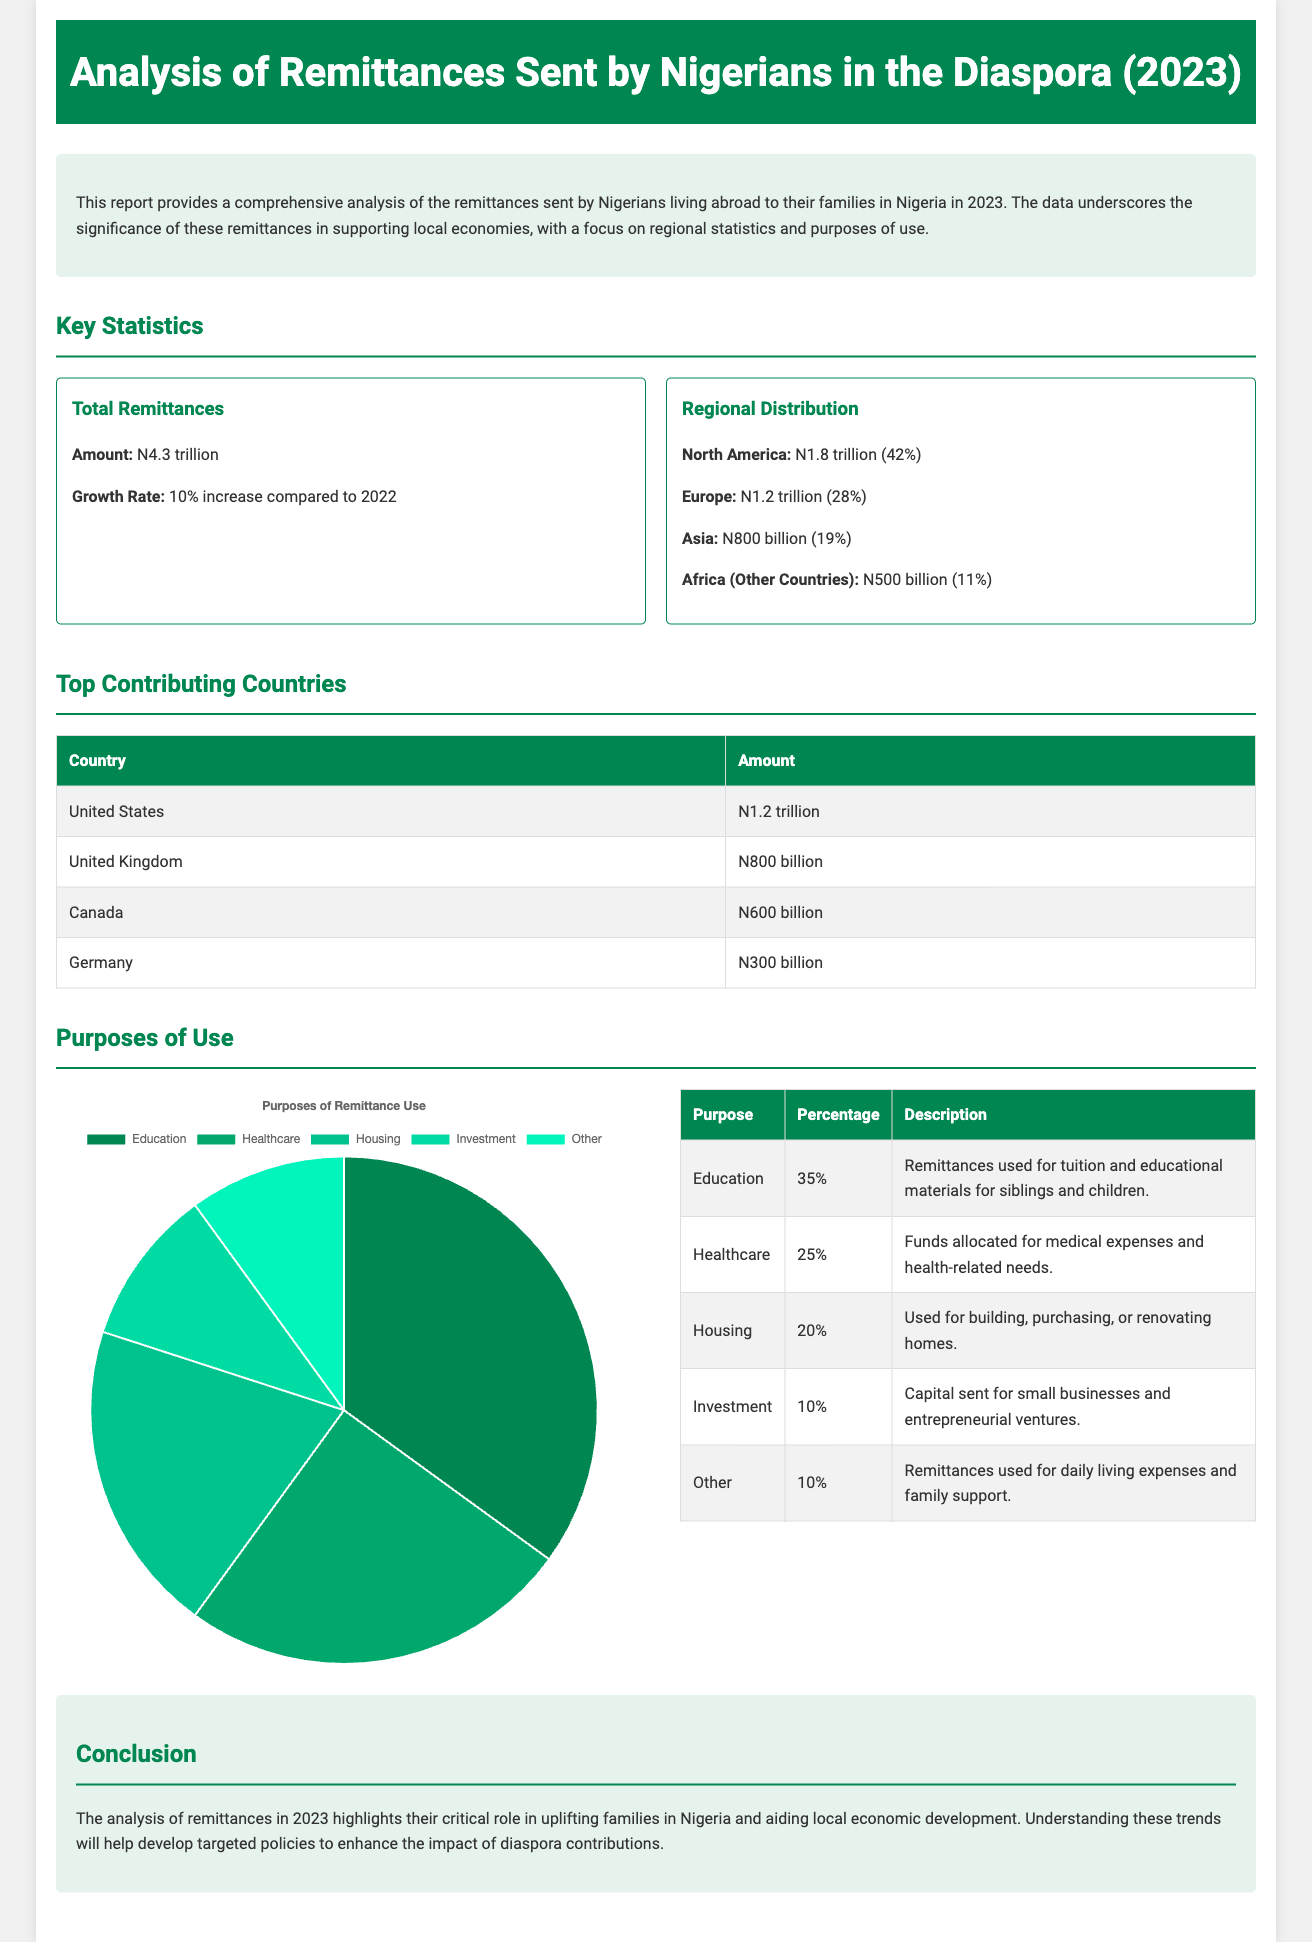what is the total amount of remittances sent by Nigerians in the diaspora in 2023? The total amount of remittances is highlighted in the document as N4.3 trillion.
Answer: N4.3 trillion what was the growth rate of remittances compared to 2022? The growth rate is indicated to be a 10% increase from the previous year.
Answer: 10% which region contributed the highest to the total remittances? The document states that North America contributed N1.8 trillion, which is the highest.
Answer: North America what percentage of remittances was used for education? The document specifies that 35% of the remittances were used for education.
Answer: 35% how much was sent from the United States specifically? The amount sent from the United States is detailed in the report as N1.2 trillion.
Answer: N1.2 trillion what purpose accounted for 25% of remittance use? The document indicates that healthcare accounted for 25% of the remittance use.
Answer: Healthcare which country sent N300 billion in remittances? The report lists Germany as the country that sent N300 billion in remittances.
Answer: Germany what is the total remittance amount from Africa (other countries)? The document notes that N500 billion was sent from Africa (other countries).
Answer: N500 billion what percentage of remittances was allocated to investment? According to the report, 10% of the remittances were allocated for investment.
Answer: 10% 